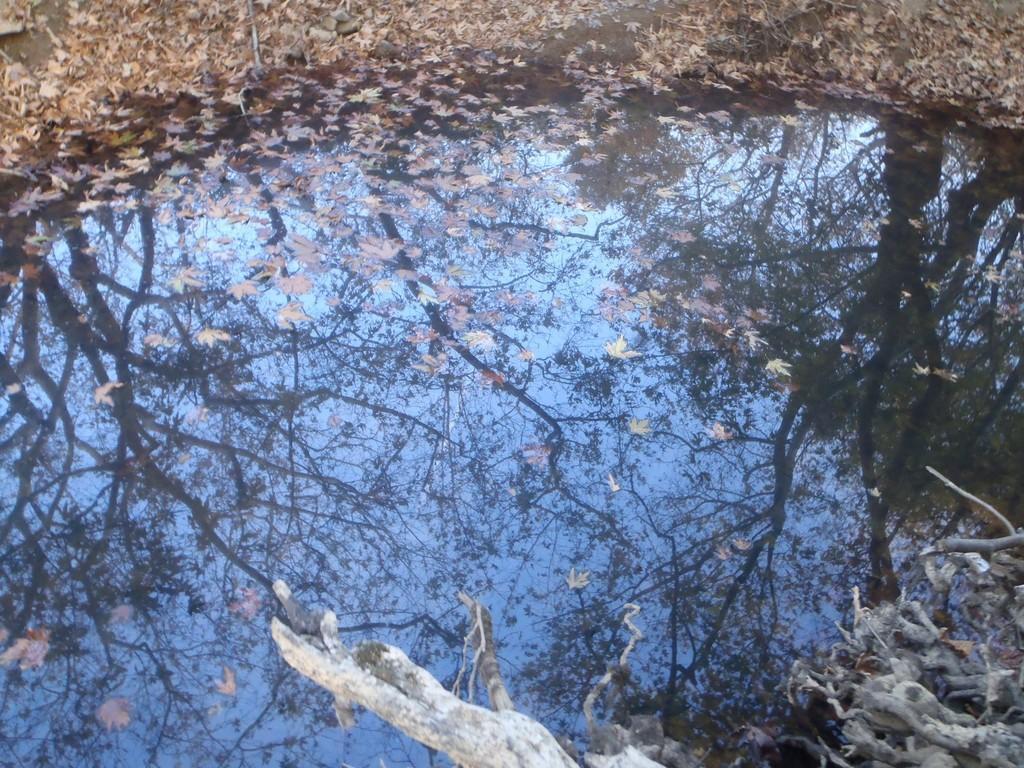Could you give a brief overview of what you see in this image? Here we can see branches, water and dried leaves. In this water there is a reflection of trees and sky. 